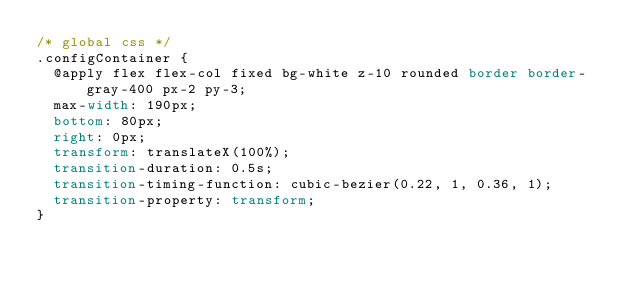<code> <loc_0><loc_0><loc_500><loc_500><_CSS_>/* global css */
.configContainer {
  @apply flex flex-col fixed bg-white z-10 rounded border border-gray-400 px-2 py-3;
  max-width: 190px;
  bottom: 80px;
  right: 0px;
  transform: translateX(100%);
  transition-duration: 0.5s;
  transition-timing-function: cubic-bezier(0.22, 1, 0.36, 1);
  transition-property: transform;
}
</code> 